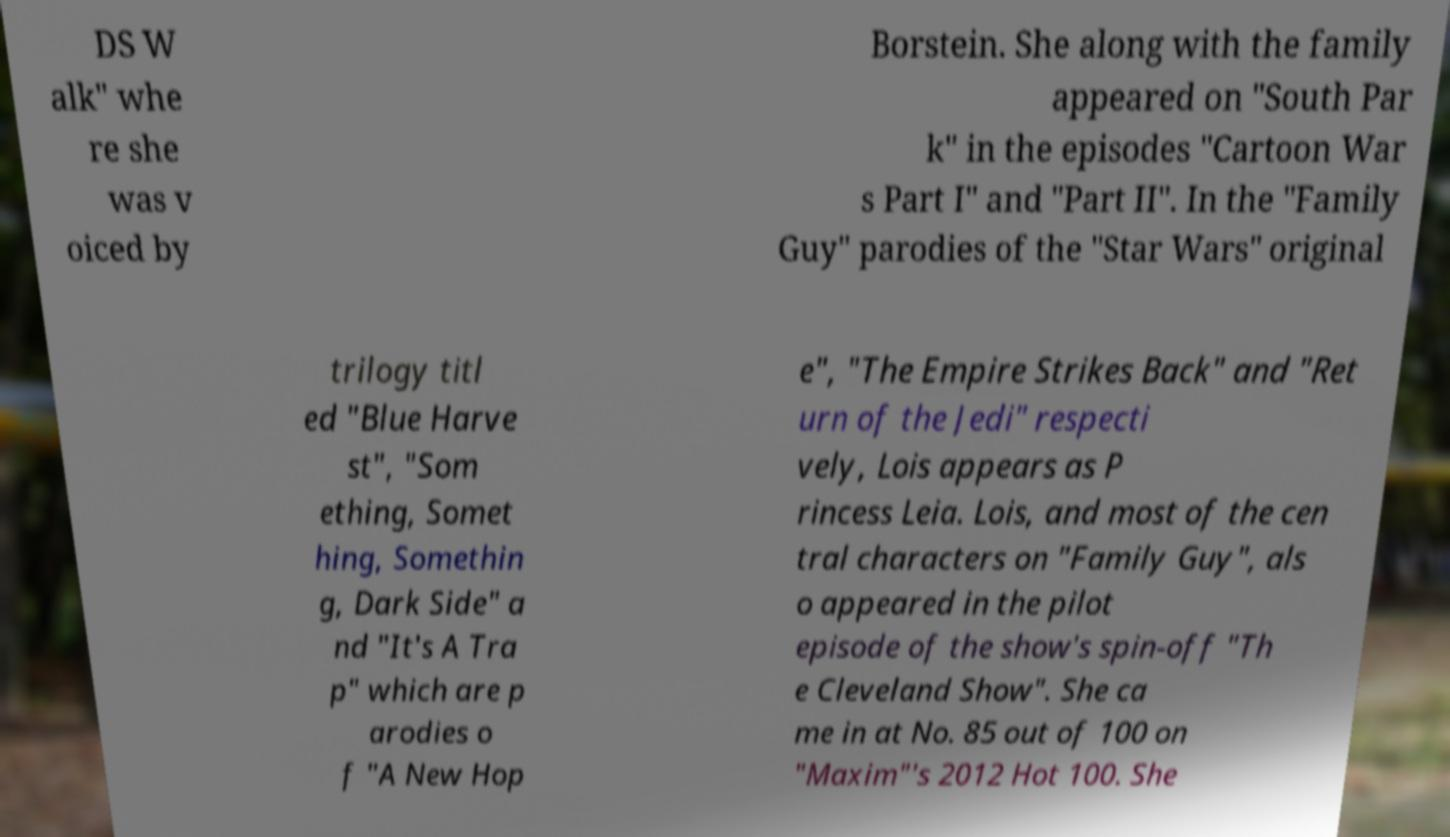I need the written content from this picture converted into text. Can you do that? DS W alk" whe re she was v oiced by Borstein. She along with the family appeared on "South Par k" in the episodes "Cartoon War s Part I" and "Part II". In the "Family Guy" parodies of the "Star Wars" original trilogy titl ed "Blue Harve st", "Som ething, Somet hing, Somethin g, Dark Side" a nd "It's A Tra p" which are p arodies o f "A New Hop e", "The Empire Strikes Back" and "Ret urn of the Jedi" respecti vely, Lois appears as P rincess Leia. Lois, and most of the cen tral characters on "Family Guy", als o appeared in the pilot episode of the show's spin-off "Th e Cleveland Show". She ca me in at No. 85 out of 100 on "Maxim"'s 2012 Hot 100. She 